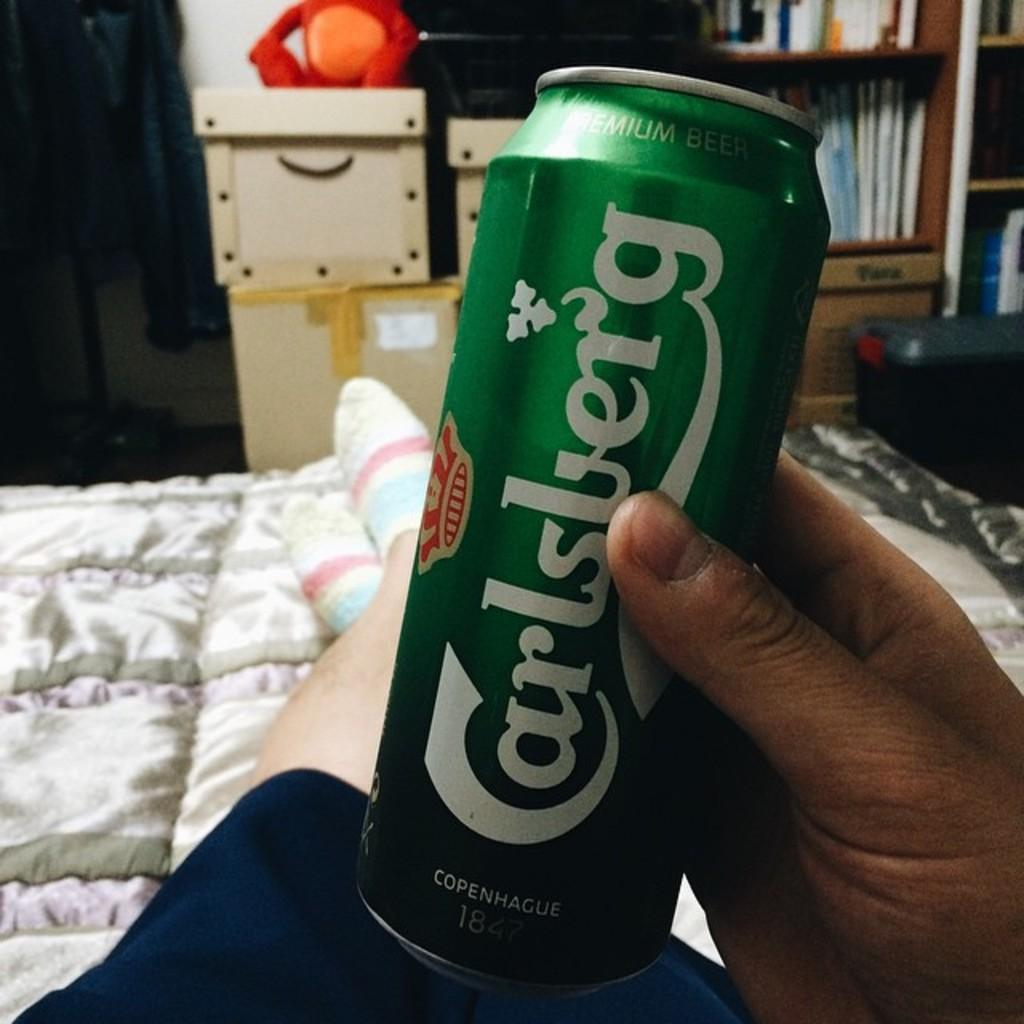<image>
Summarize the visual content of the image. A man is laying on a bed holding a can of Carlsberg. 